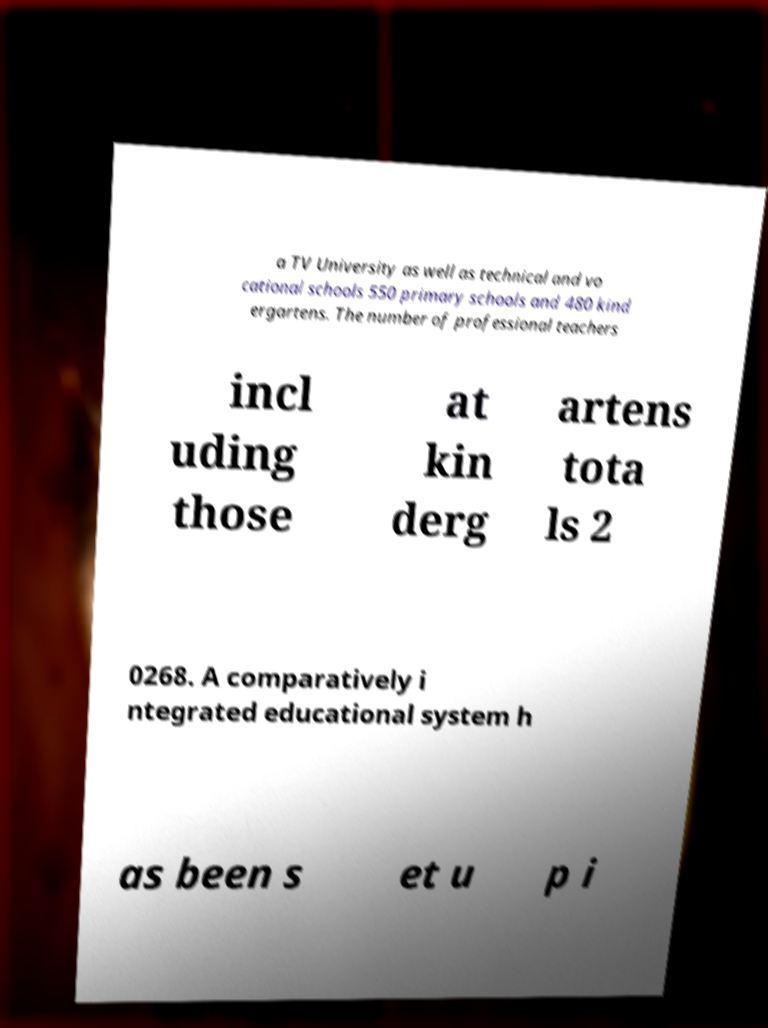Can you read and provide the text displayed in the image?This photo seems to have some interesting text. Can you extract and type it out for me? a TV University as well as technical and vo cational schools 550 primary schools and 480 kind ergartens. The number of professional teachers incl uding those at kin derg artens tota ls 2 0268. A comparatively i ntegrated educational system h as been s et u p i 